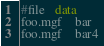<code> <loc_0><loc_0><loc_500><loc_500><_SQL_>#file   data
foo.mgf	bar
foo.mgf	bar4
</code> 